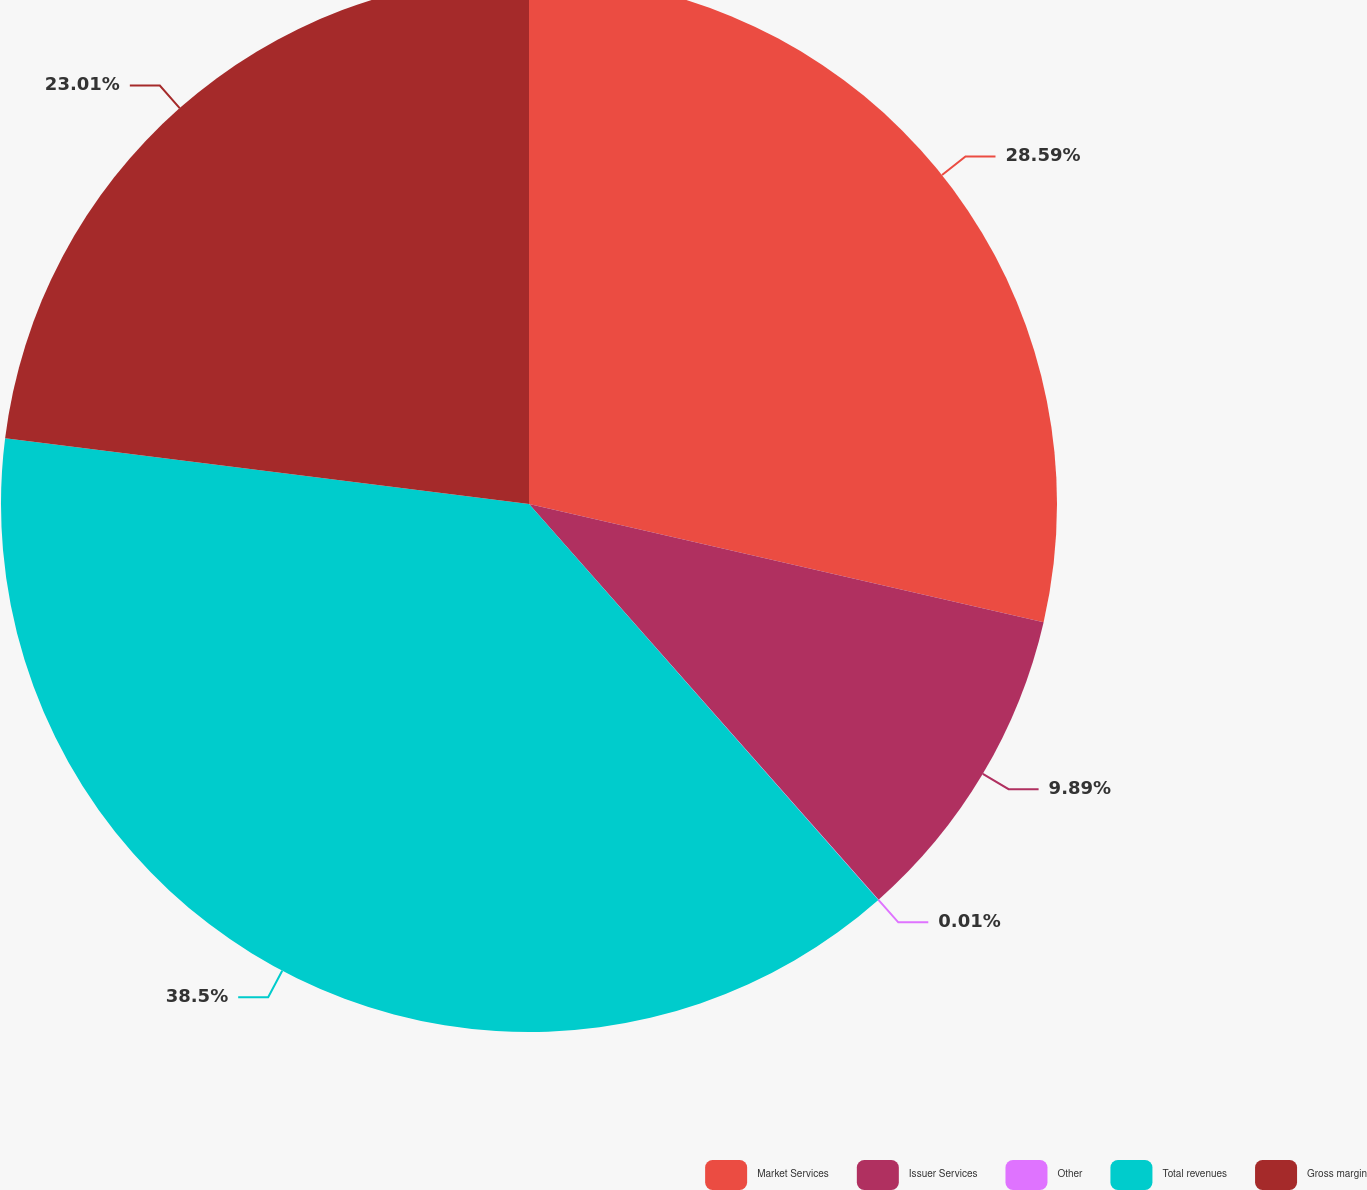Convert chart. <chart><loc_0><loc_0><loc_500><loc_500><pie_chart><fcel>Market Services<fcel>Issuer Services<fcel>Other<fcel>Total revenues<fcel>Gross margin<nl><fcel>28.59%<fcel>9.89%<fcel>0.01%<fcel>38.49%<fcel>23.01%<nl></chart> 